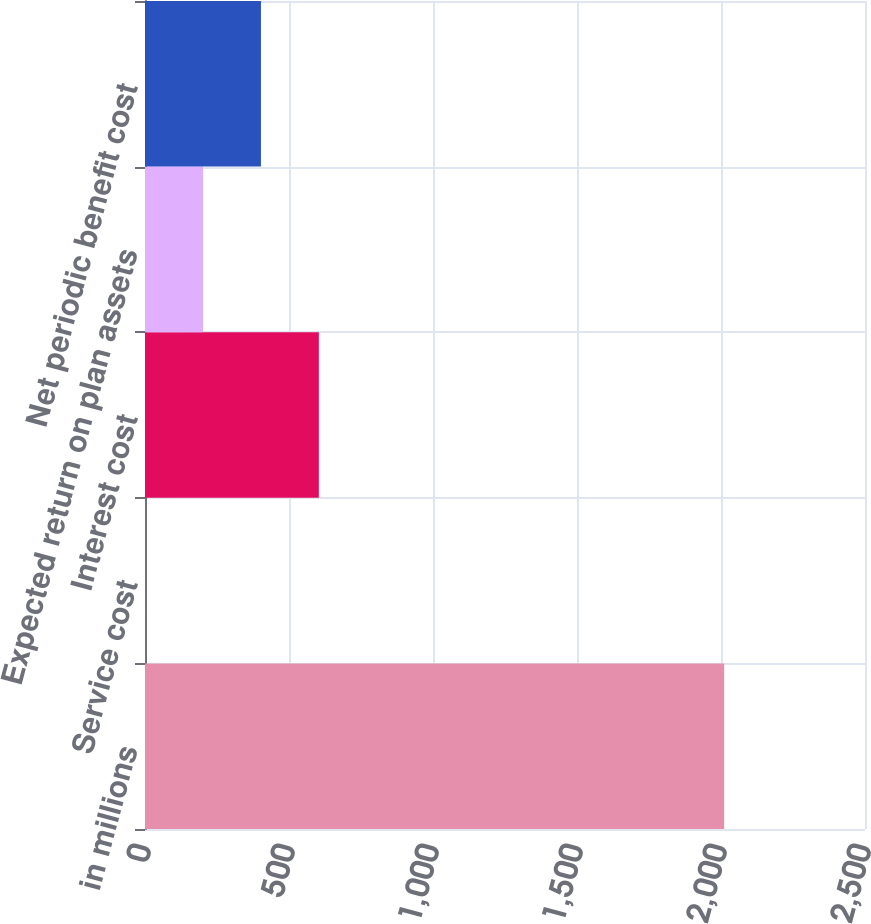Convert chart to OTSL. <chart><loc_0><loc_0><loc_500><loc_500><bar_chart><fcel>in millions<fcel>Service cost<fcel>Interest cost<fcel>Expected return on plan assets<fcel>Net periodic benefit cost<nl><fcel>2011<fcel>0.5<fcel>603.65<fcel>201.55<fcel>402.6<nl></chart> 